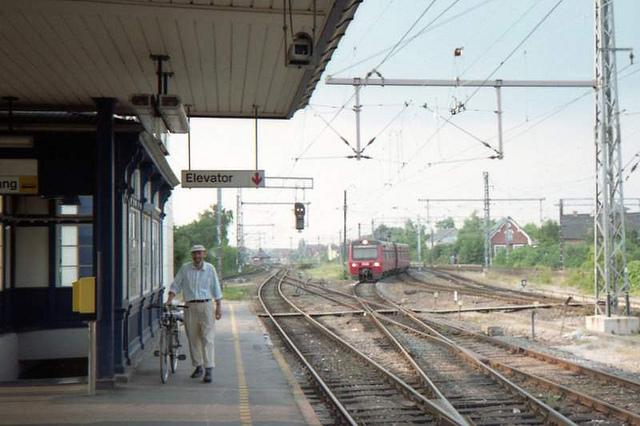How many tracks are here?
Short answer required. 5. What color is the train?
Quick response, please. Red. Are there any humans in the picture?
Be succinct. Yes. Are there any people in front of the yellow line?
Quick response, please. No. Is a passenger getting off the train?
Concise answer only. No. Is this daytime or night time?
Concise answer only. Daytime. 